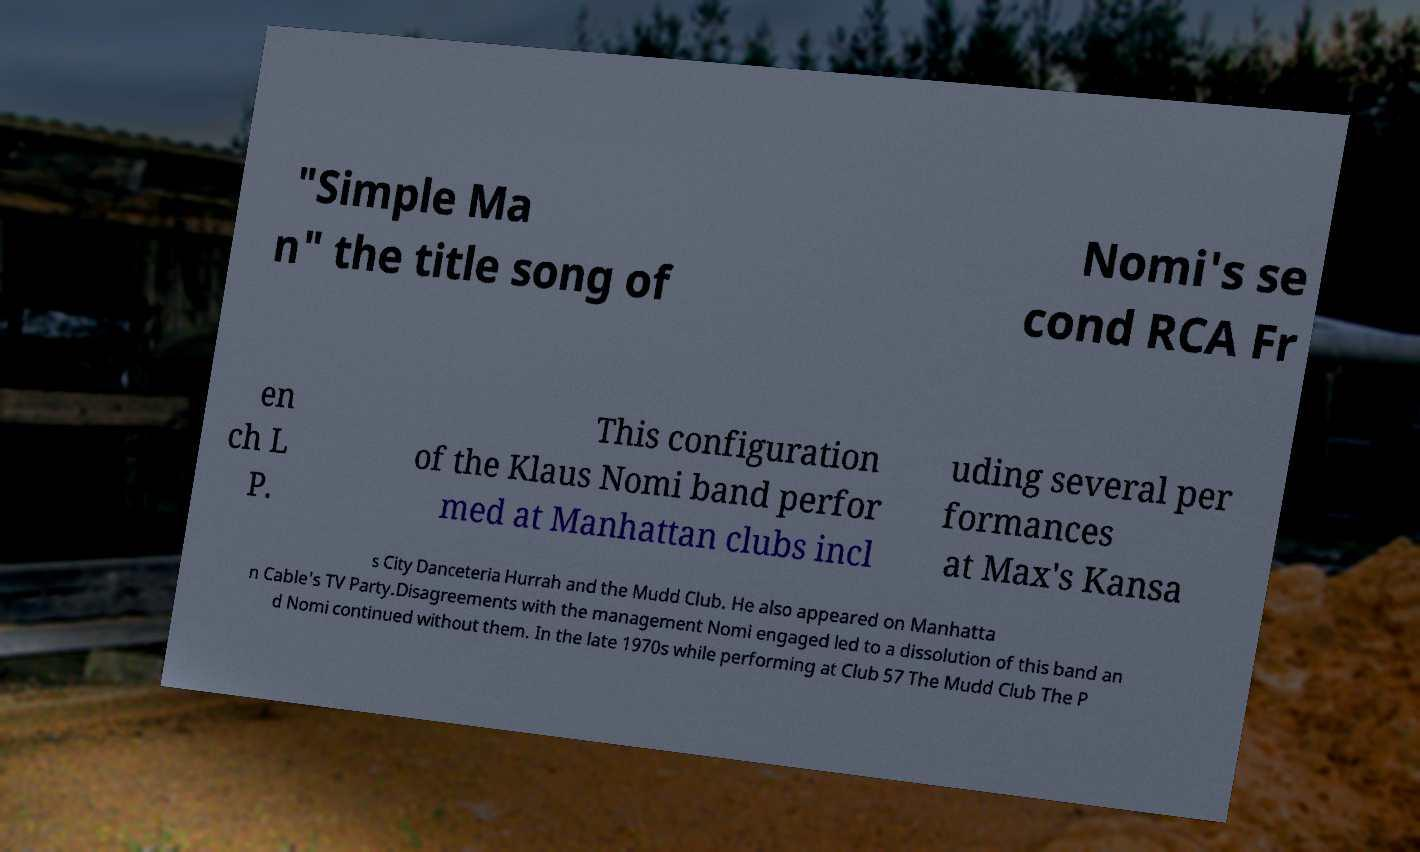For documentation purposes, I need the text within this image transcribed. Could you provide that? "Simple Ma n" the title song of Nomi's se cond RCA Fr en ch L P. This configuration of the Klaus Nomi band perfor med at Manhattan clubs incl uding several per formances at Max's Kansa s City Danceteria Hurrah and the Mudd Club. He also appeared on Manhatta n Cable's TV Party.Disagreements with the management Nomi engaged led to a dissolution of this band an d Nomi continued without them. In the late 1970s while performing at Club 57 The Mudd Club The P 